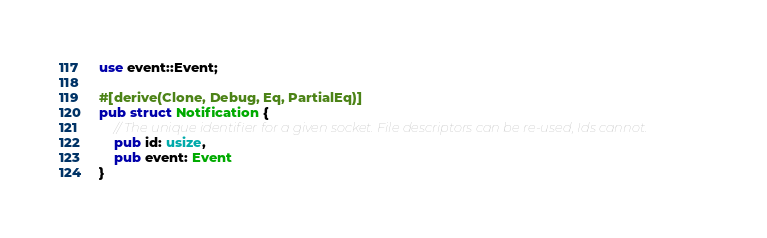<code> <loc_0><loc_0><loc_500><loc_500><_Rust_>use event::Event;

#[derive(Clone, Debug, Eq, PartialEq)]
pub struct Notification {
    // The unique identifier for a given socket. File descriptors can be re-used, Ids cannot.
    pub id: usize,
    pub event: Event
}
</code> 